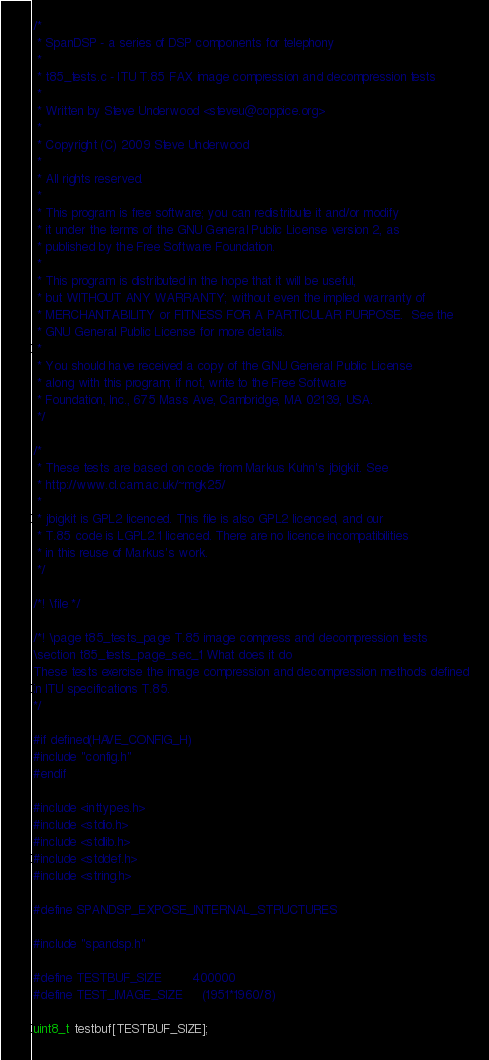<code> <loc_0><loc_0><loc_500><loc_500><_C_>/*
 * SpanDSP - a series of DSP components for telephony
 *
 * t85_tests.c - ITU T.85 FAX image compression and decompression tests
 *
 * Written by Steve Underwood <steveu@coppice.org>
 *
 * Copyright (C) 2009 Steve Underwood
 *
 * All rights reserved.
 *
 * This program is free software; you can redistribute it and/or modify
 * it under the terms of the GNU General Public License version 2, as
 * published by the Free Software Foundation.
 *
 * This program is distributed in the hope that it will be useful,
 * but WITHOUT ANY WARRANTY; without even the implied warranty of
 * MERCHANTABILITY or FITNESS FOR A PARTICULAR PURPOSE.  See the
 * GNU General Public License for more details.
 *
 * You should have received a copy of the GNU General Public License
 * along with this program; if not, write to the Free Software
 * Foundation, Inc., 675 Mass Ave, Cambridge, MA 02139, USA.
 */

/*
 * These tests are based on code from Markus Kuhn's jbigkit. See
 * http://www.cl.cam.ac.uk/~mgk25/
 *
 * jbigkit is GPL2 licenced. This file is also GPL2 licenced, and our
 * T.85 code is LGPL2.1 licenced. There are no licence incompatibilities
 * in this reuse of Markus's work.
 */

/*! \file */

/*! \page t85_tests_page T.85 image compress and decompression tests
\section t85_tests_page_sec_1 What does it do
These tests exercise the image compression and decompression methods defined
in ITU specifications T.85.
*/

#if defined(HAVE_CONFIG_H)
#include "config.h"
#endif

#include <inttypes.h>
#include <stdio.h>
#include <stdlib.h>
#include <stddef.h>
#include <string.h>

#define SPANDSP_EXPOSE_INTERNAL_STRUCTURES

#include "spandsp.h"

#define TESTBUF_SIZE        400000
#define TEST_IMAGE_SIZE     (1951*1960/8)

uint8_t testbuf[TESTBUF_SIZE];</code> 